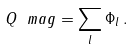Convert formula to latex. <formula><loc_0><loc_0><loc_500><loc_500>Q _ { \ } m a g = \sum _ { l } \Phi _ { l } \, .</formula> 